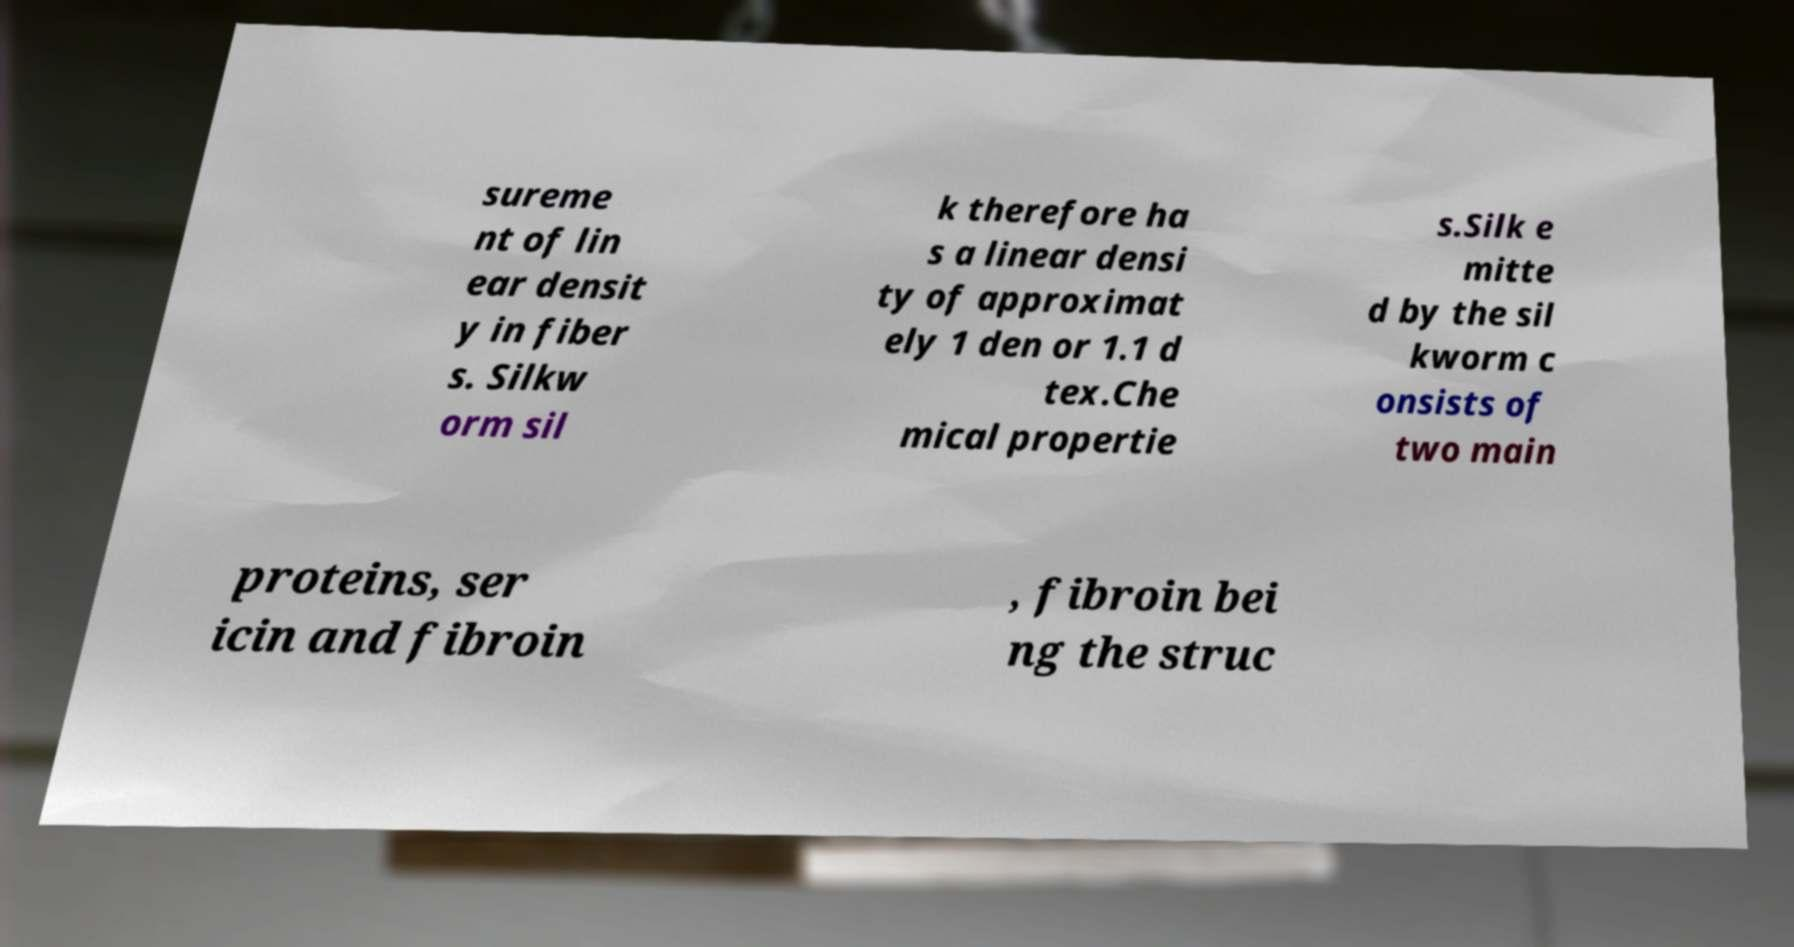Can you read and provide the text displayed in the image?This photo seems to have some interesting text. Can you extract and type it out for me? sureme nt of lin ear densit y in fiber s. Silkw orm sil k therefore ha s a linear densi ty of approximat ely 1 den or 1.1 d tex.Che mical propertie s.Silk e mitte d by the sil kworm c onsists of two main proteins, ser icin and fibroin , fibroin bei ng the struc 